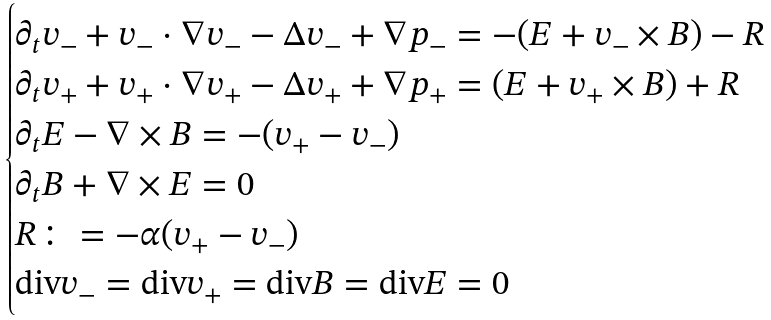<formula> <loc_0><loc_0><loc_500><loc_500>\begin{cases} \partial _ { t } v _ { - } + v _ { - } \cdot \nabla v _ { - } - \Delta v _ { - } + \nabla p _ { - } = - ( E + v _ { - } \times B ) - R \\ \partial _ { t } v _ { + } + v _ { + } \cdot \nabla v _ { + } - \Delta v _ { + } + \nabla p _ { + } = ( E + v _ { + } \times B ) + R \\ \partial _ { t } E - \nabla \times B = - ( v _ { + } - v _ { - } ) \\ \partial _ { t } B + \nabla \times E = 0 \\ R \colon = - \alpha ( v _ { + } - v _ { - } ) \\ \text {div} v _ { - } = \text {div} v _ { + } = \text {div} B = \text {div} E = 0 \\ \end{cases}</formula> 